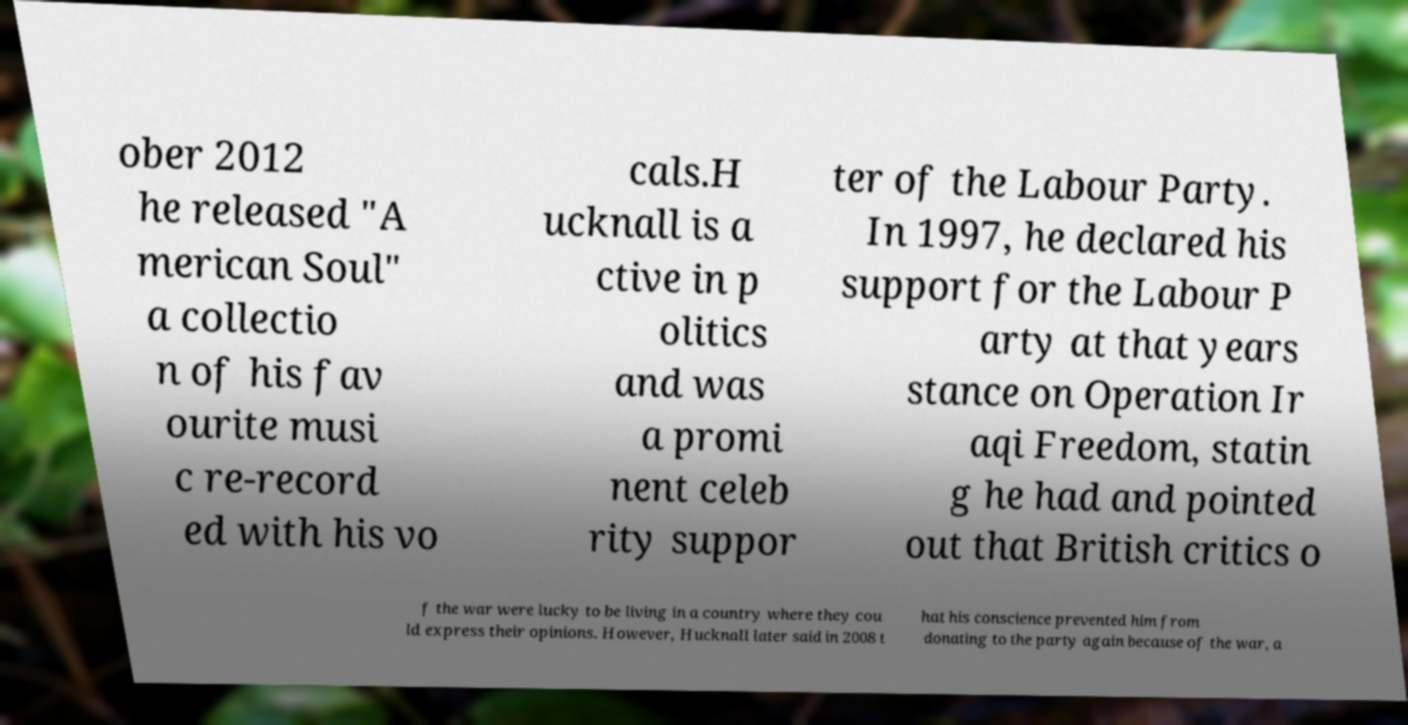Please identify and transcribe the text found in this image. ober 2012 he released "A merican Soul" a collectio n of his fav ourite musi c re-record ed with his vo cals.H ucknall is a ctive in p olitics and was a promi nent celeb rity suppor ter of the Labour Party. In 1997, he declared his support for the Labour P arty at that years stance on Operation Ir aqi Freedom, statin g he had and pointed out that British critics o f the war were lucky to be living in a country where they cou ld express their opinions. However, Hucknall later said in 2008 t hat his conscience prevented him from donating to the party again because of the war, a 